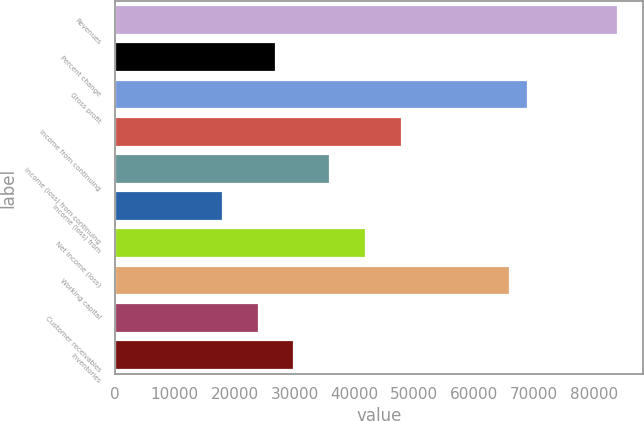<chart> <loc_0><loc_0><loc_500><loc_500><bar_chart><fcel>Revenues<fcel>Percent change<fcel>Gross profit<fcel>Income from continuing<fcel>Income (loss) from continuing<fcel>Income (loss) from<fcel>Net income (loss)<fcel>Working capital<fcel>Customer receivables<fcel>Inventories<nl><fcel>83943.2<fcel>26981.8<fcel>68953.4<fcel>47967.6<fcel>35975.7<fcel>17987.9<fcel>41971.7<fcel>65955.4<fcel>23983.8<fcel>29979.8<nl></chart> 